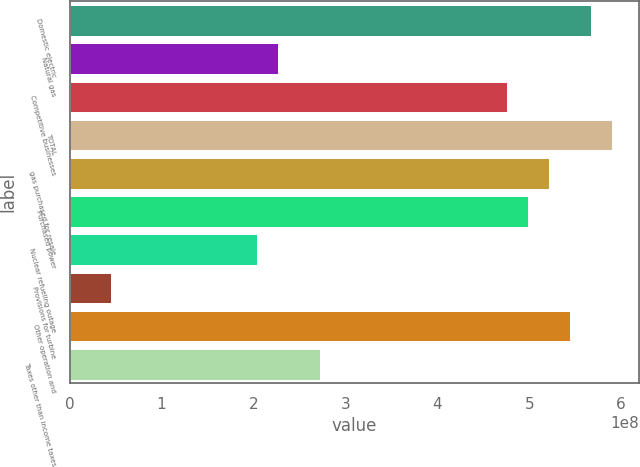<chart> <loc_0><loc_0><loc_500><loc_500><bar_chart><fcel>Domestic electric<fcel>Natural gas<fcel>Competitive businesses<fcel>TOTAL<fcel>gas purchased for resale<fcel>Purchased power<fcel>Nuclear refueling outage<fcel>Provisions for turbine<fcel>Other operation and<fcel>Taxes other than income taxes<nl><fcel>5.67011e+08<fcel>2.26804e+08<fcel>4.76289e+08<fcel>5.89691e+08<fcel>5.2165e+08<fcel>4.9897e+08<fcel>2.04124e+08<fcel>4.53609e+07<fcel>5.4433e+08<fcel>2.72165e+08<nl></chart> 